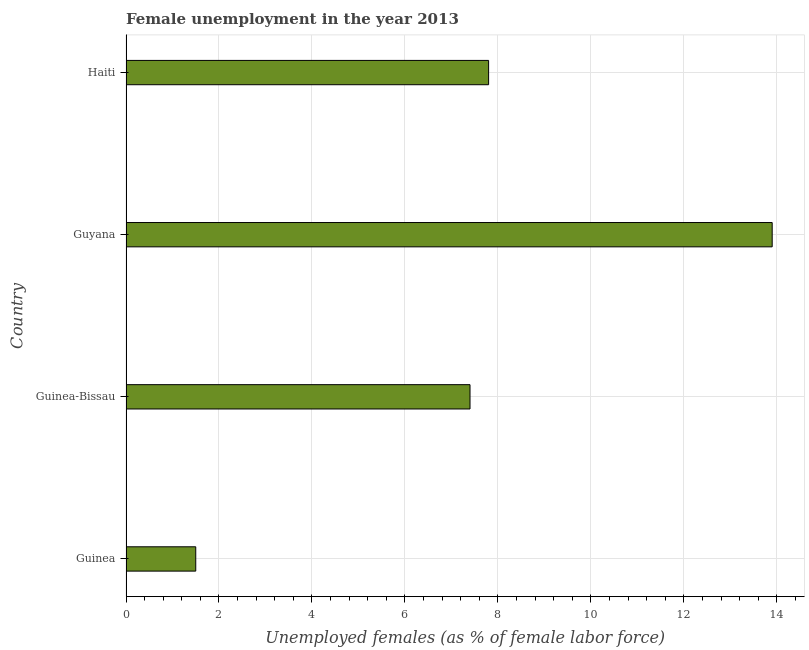Does the graph contain grids?
Provide a short and direct response. Yes. What is the title of the graph?
Provide a succinct answer. Female unemployment in the year 2013. What is the label or title of the X-axis?
Offer a terse response. Unemployed females (as % of female labor force). What is the unemployed females population in Guinea-Bissau?
Your answer should be compact. 7.4. Across all countries, what is the maximum unemployed females population?
Offer a terse response. 13.9. In which country was the unemployed females population maximum?
Your answer should be very brief. Guyana. In which country was the unemployed females population minimum?
Provide a succinct answer. Guinea. What is the sum of the unemployed females population?
Offer a terse response. 30.6. What is the difference between the unemployed females population in Guinea and Haiti?
Your answer should be very brief. -6.3. What is the average unemployed females population per country?
Offer a very short reply. 7.65. What is the median unemployed females population?
Provide a short and direct response. 7.6. What is the ratio of the unemployed females population in Guinea-Bissau to that in Haiti?
Keep it short and to the point. 0.95. Is the unemployed females population in Guinea less than that in Haiti?
Provide a short and direct response. Yes. Is the sum of the unemployed females population in Guinea and Guyana greater than the maximum unemployed females population across all countries?
Provide a short and direct response. Yes. What is the difference between the highest and the lowest unemployed females population?
Your answer should be compact. 12.4. In how many countries, is the unemployed females population greater than the average unemployed females population taken over all countries?
Offer a terse response. 2. How many countries are there in the graph?
Provide a succinct answer. 4. What is the difference between two consecutive major ticks on the X-axis?
Your response must be concise. 2. What is the Unemployed females (as % of female labor force) of Guinea?
Give a very brief answer. 1.5. What is the Unemployed females (as % of female labor force) in Guinea-Bissau?
Offer a very short reply. 7.4. What is the Unemployed females (as % of female labor force) in Guyana?
Your answer should be compact. 13.9. What is the Unemployed females (as % of female labor force) of Haiti?
Give a very brief answer. 7.8. What is the difference between the Unemployed females (as % of female labor force) in Guinea-Bissau and Guyana?
Provide a short and direct response. -6.5. What is the ratio of the Unemployed females (as % of female labor force) in Guinea to that in Guinea-Bissau?
Offer a very short reply. 0.2. What is the ratio of the Unemployed females (as % of female labor force) in Guinea to that in Guyana?
Ensure brevity in your answer.  0.11. What is the ratio of the Unemployed females (as % of female labor force) in Guinea to that in Haiti?
Provide a succinct answer. 0.19. What is the ratio of the Unemployed females (as % of female labor force) in Guinea-Bissau to that in Guyana?
Ensure brevity in your answer.  0.53. What is the ratio of the Unemployed females (as % of female labor force) in Guinea-Bissau to that in Haiti?
Provide a short and direct response. 0.95. What is the ratio of the Unemployed females (as % of female labor force) in Guyana to that in Haiti?
Your response must be concise. 1.78. 